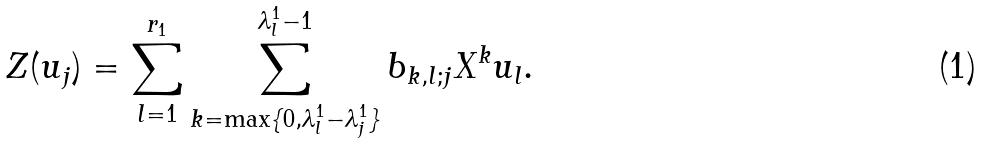Convert formula to latex. <formula><loc_0><loc_0><loc_500><loc_500>Z ( u _ { j } ) = \sum _ { l = 1 } ^ { r _ { 1 } } \sum _ { k = \max \{ 0 , \lambda ^ { 1 } _ { l } - \lambda ^ { 1 } _ { j } \} } ^ { \lambda ^ { 1 } _ { l } - 1 } b _ { k , l ; j } X ^ { k } u _ { l } .</formula> 